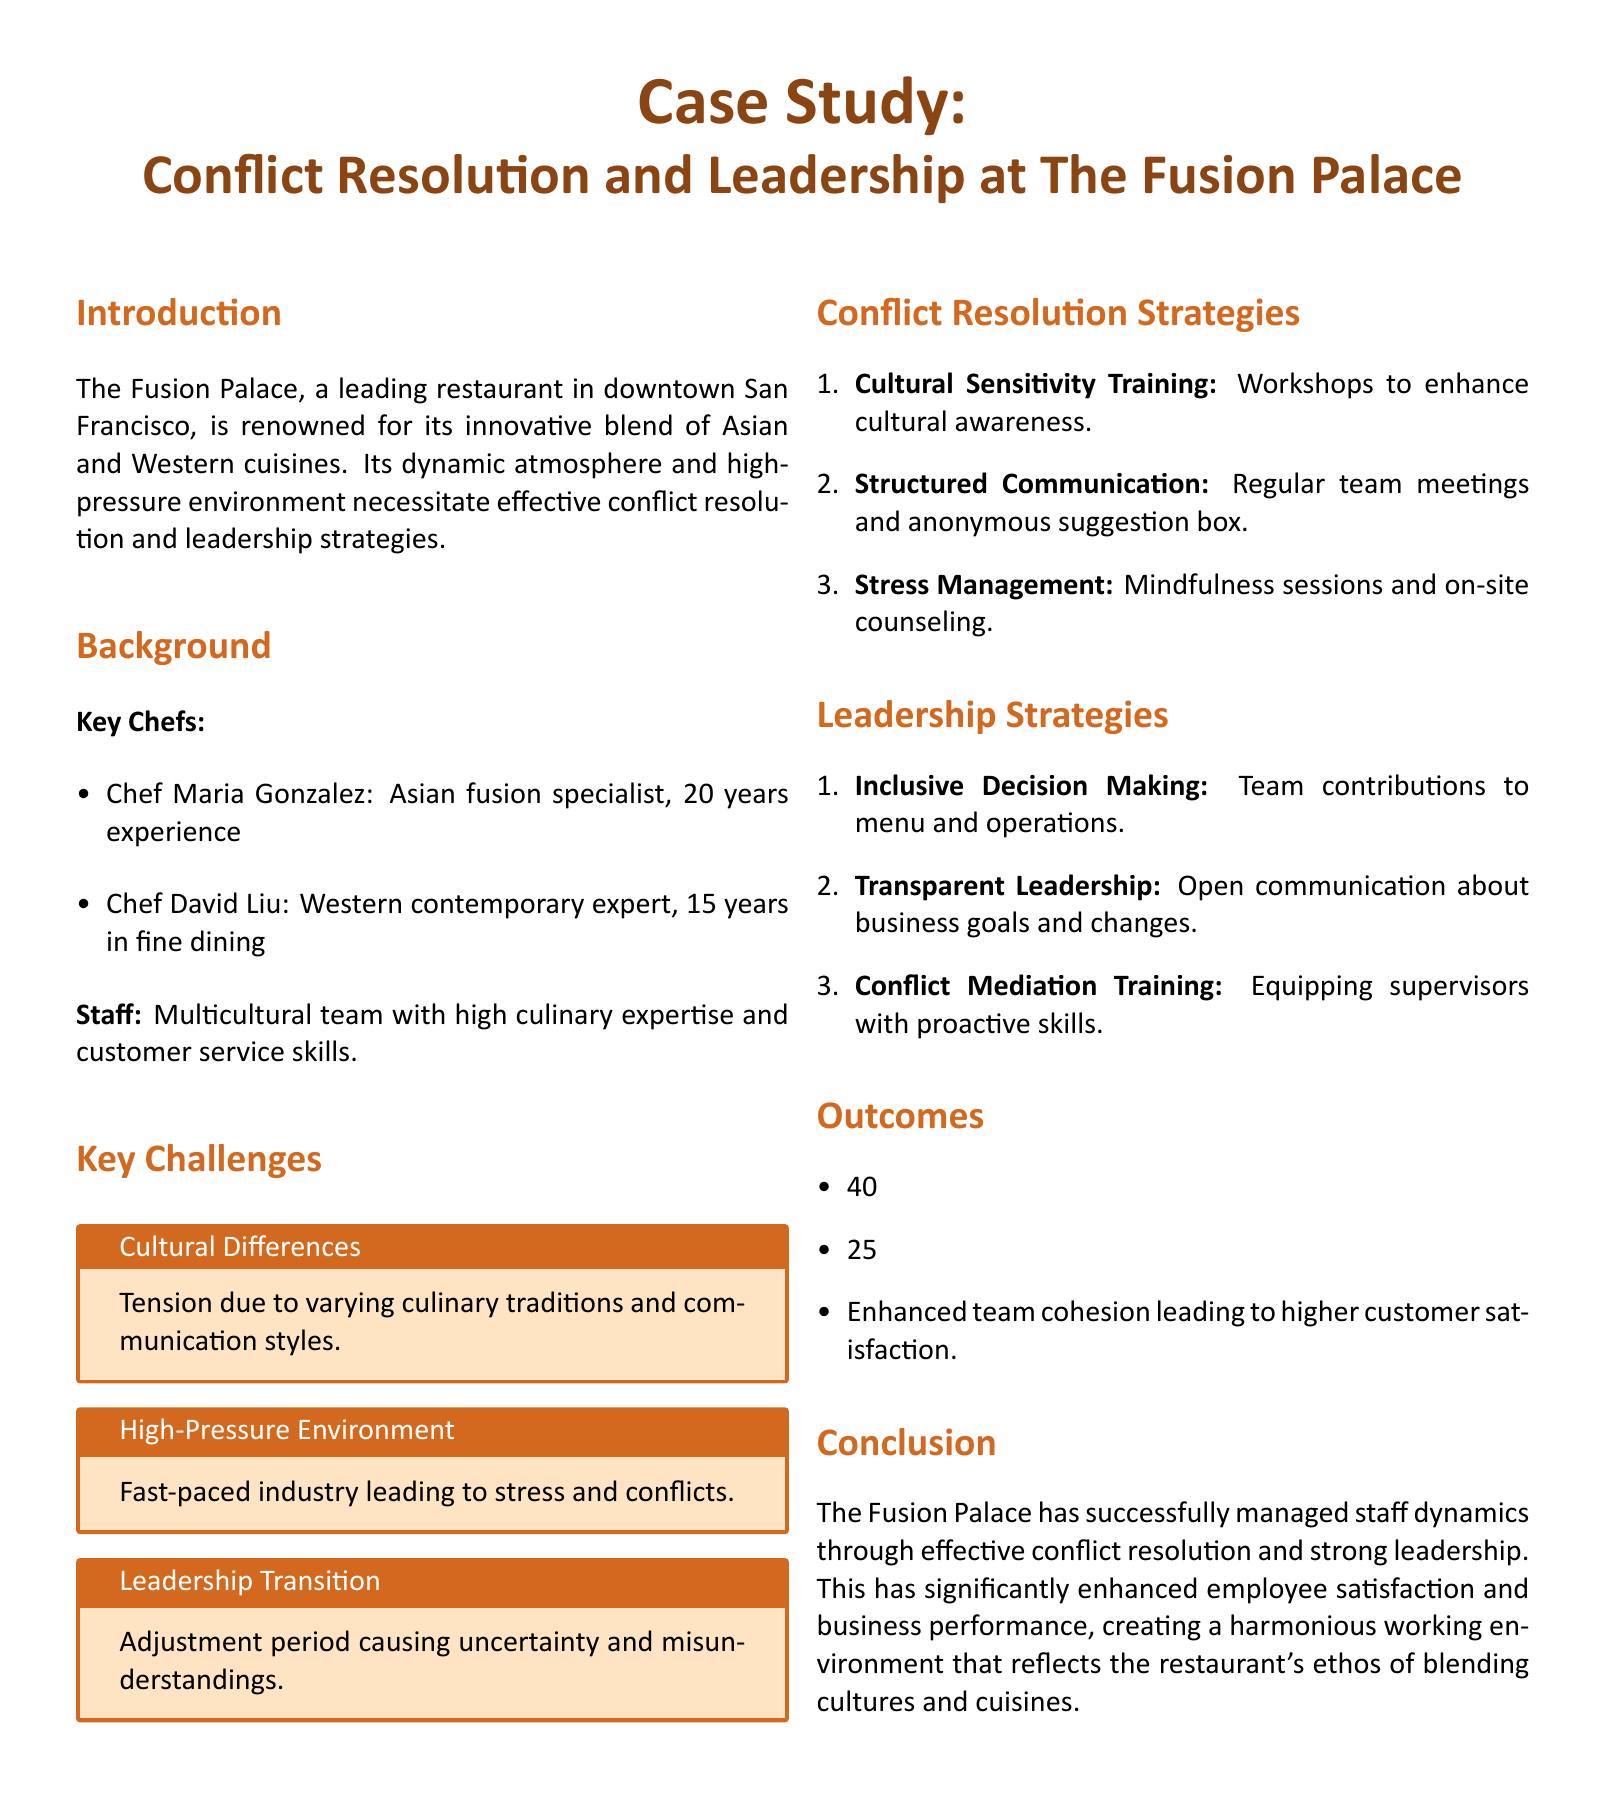What are the names of the key chefs? The document lists two key chefs at The Fusion Palace, which are Chef Maria Gonzalez and Chef David Liu.
Answer: Chef Maria Gonzalez, Chef David Liu What percentage reduction in staff conflicts was achieved? The outcomes section states a 40% reduction in staff conflicts within six months.
Answer: 40% What training enhances cultural awareness among staff? The document mentions cultural sensitivity training workshops as a strategy to improve cultural awareness.
Answer: Cultural Sensitivity Training What type of sessions were introduced for stress management? The document indicates that mindfulness sessions and on-site counseling were implemented for stress management.
Answer: Mindfulness sessions, on-site counseling What was a key challenge related to the working environment? The document highlights the "High-Pressure Environment" as a key challenge faced by the staff.
Answer: High-Pressure Environment How much did staff satisfaction scores increase? The document notes a 25% increase in staff satisfaction scores as an outcome.
Answer: 25% What leadership strategy involves team contributions? The document describes "Inclusive Decision Making" as a leadership strategy where team contributions to the menu and operations are encouraged.
Answer: Inclusive Decision Making Which city is The Fusion Palace located in? The introduction states that The Fusion Palace is located in downtown San Francisco.
Answer: San Francisco 